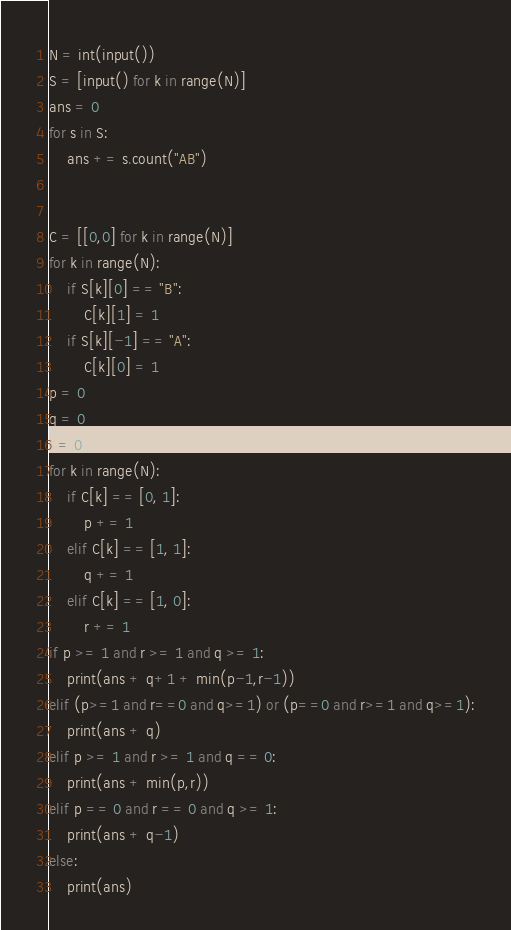Convert code to text. <code><loc_0><loc_0><loc_500><loc_500><_Python_>N = int(input())
S = [input() for k in range(N)]
ans = 0
for s in S:
    ans += s.count("AB")


C = [[0,0] for k in range(N)]
for k in range(N):
    if S[k][0] == "B":
        C[k][1] = 1
    if S[k][-1] == "A":
        C[k][0] = 1
p = 0
q = 0
r = 0
for k in range(N):
    if C[k] == [0, 1]:
        p += 1
    elif C[k] == [1, 1]:
        q += 1
    elif C[k] == [1, 0]:
        r += 1
if p >= 1 and r >= 1 and q >= 1:
    print(ans + q+1 + min(p-1,r-1))
elif (p>=1 and r==0 and q>=1) or (p==0 and r>=1 and q>=1):
    print(ans + q)
elif p >= 1 and r >= 1 and q == 0:
    print(ans + min(p,r))
elif p == 0 and r == 0 and q >= 1:
    print(ans + q-1)
else:
    print(ans)</code> 